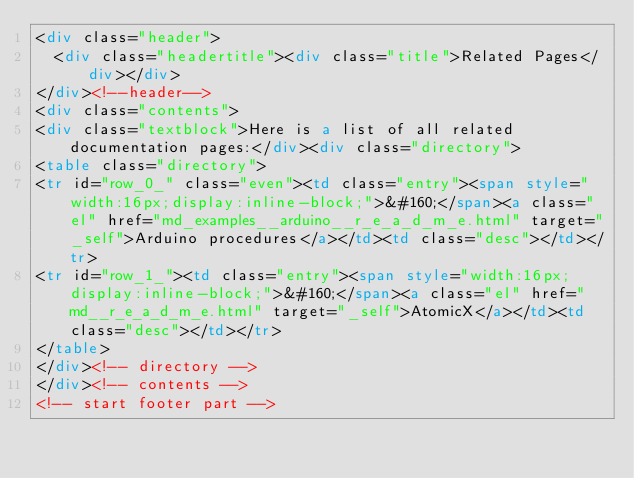Convert code to text. <code><loc_0><loc_0><loc_500><loc_500><_HTML_><div class="header">
  <div class="headertitle"><div class="title">Related Pages</div></div>
</div><!--header-->
<div class="contents">
<div class="textblock">Here is a list of all related documentation pages:</div><div class="directory">
<table class="directory">
<tr id="row_0_" class="even"><td class="entry"><span style="width:16px;display:inline-block;">&#160;</span><a class="el" href="md_examples__arduino__r_e_a_d_m_e.html" target="_self">Arduino procedures</a></td><td class="desc"></td></tr>
<tr id="row_1_"><td class="entry"><span style="width:16px;display:inline-block;">&#160;</span><a class="el" href="md__r_e_a_d_m_e.html" target="_self">AtomicX</a></td><td class="desc"></td></tr>
</table>
</div><!-- directory -->
</div><!-- contents -->
<!-- start footer part --></code> 